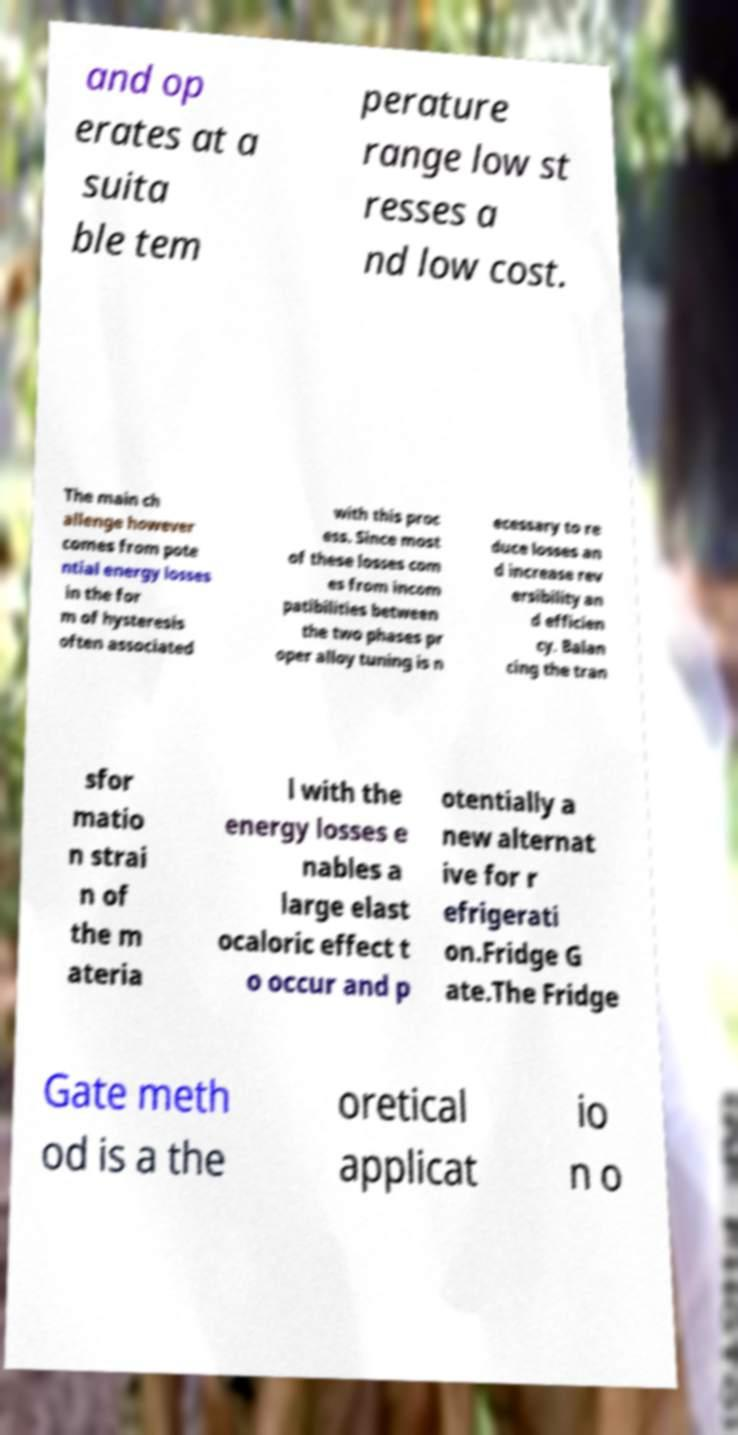I need the written content from this picture converted into text. Can you do that? and op erates at a suita ble tem perature range low st resses a nd low cost. The main ch allenge however comes from pote ntial energy losses in the for m of hysteresis often associated with this proc ess. Since most of these losses com es from incom patibilities between the two phases pr oper alloy tuning is n ecessary to re duce losses an d increase rev ersibility an d efficien cy. Balan cing the tran sfor matio n strai n of the m ateria l with the energy losses e nables a large elast ocaloric effect t o occur and p otentially a new alternat ive for r efrigerati on.Fridge G ate.The Fridge Gate meth od is a the oretical applicat io n o 